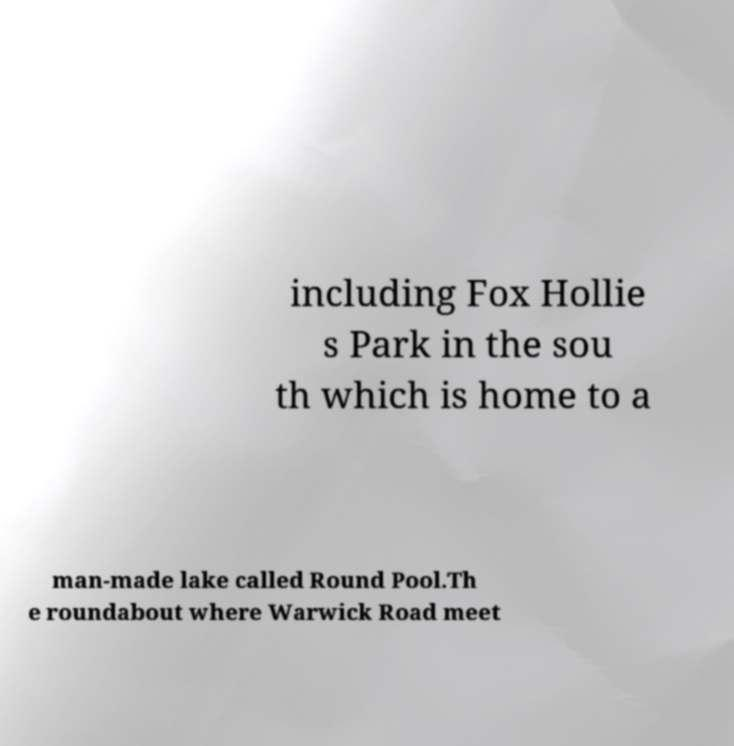Can you accurately transcribe the text from the provided image for me? including Fox Hollie s Park in the sou th which is home to a man-made lake called Round Pool.Th e roundabout where Warwick Road meet 